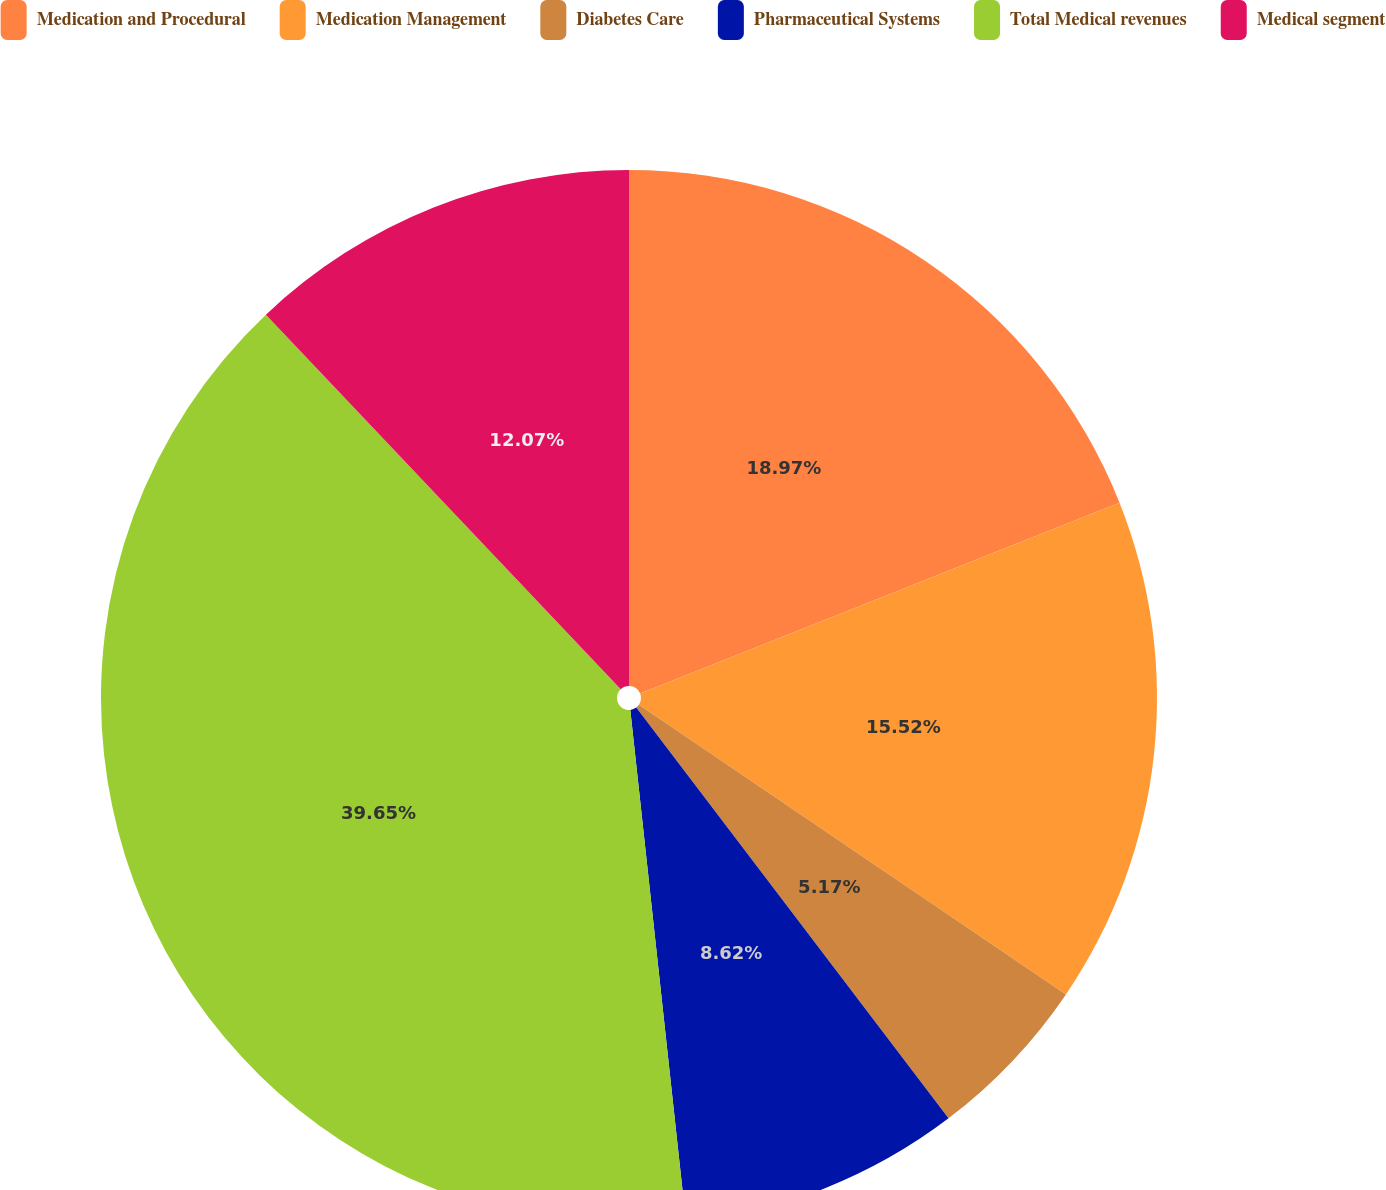Convert chart. <chart><loc_0><loc_0><loc_500><loc_500><pie_chart><fcel>Medication and Procedural<fcel>Medication Management<fcel>Diabetes Care<fcel>Pharmaceutical Systems<fcel>Total Medical revenues<fcel>Medical segment<nl><fcel>18.97%<fcel>15.52%<fcel>5.17%<fcel>8.62%<fcel>39.66%<fcel>12.07%<nl></chart> 